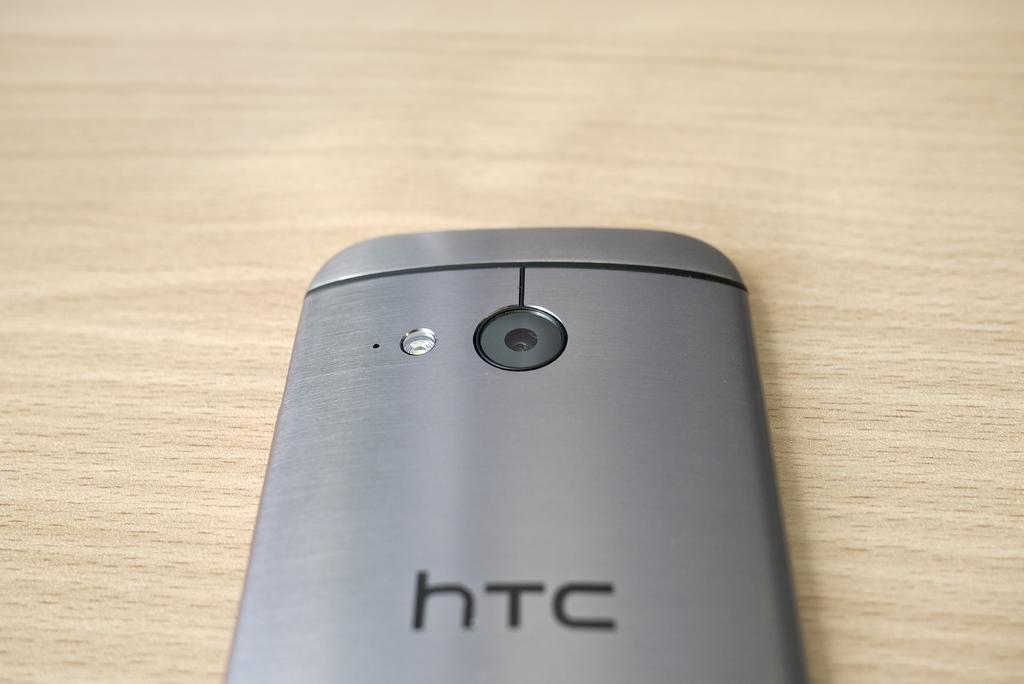<image>
Summarize the visual content of the image. the back of an HTC silver phone on a wooden surface 